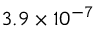<formula> <loc_0><loc_0><loc_500><loc_500>3 . 9 \times 1 0 ^ { - 7 }</formula> 